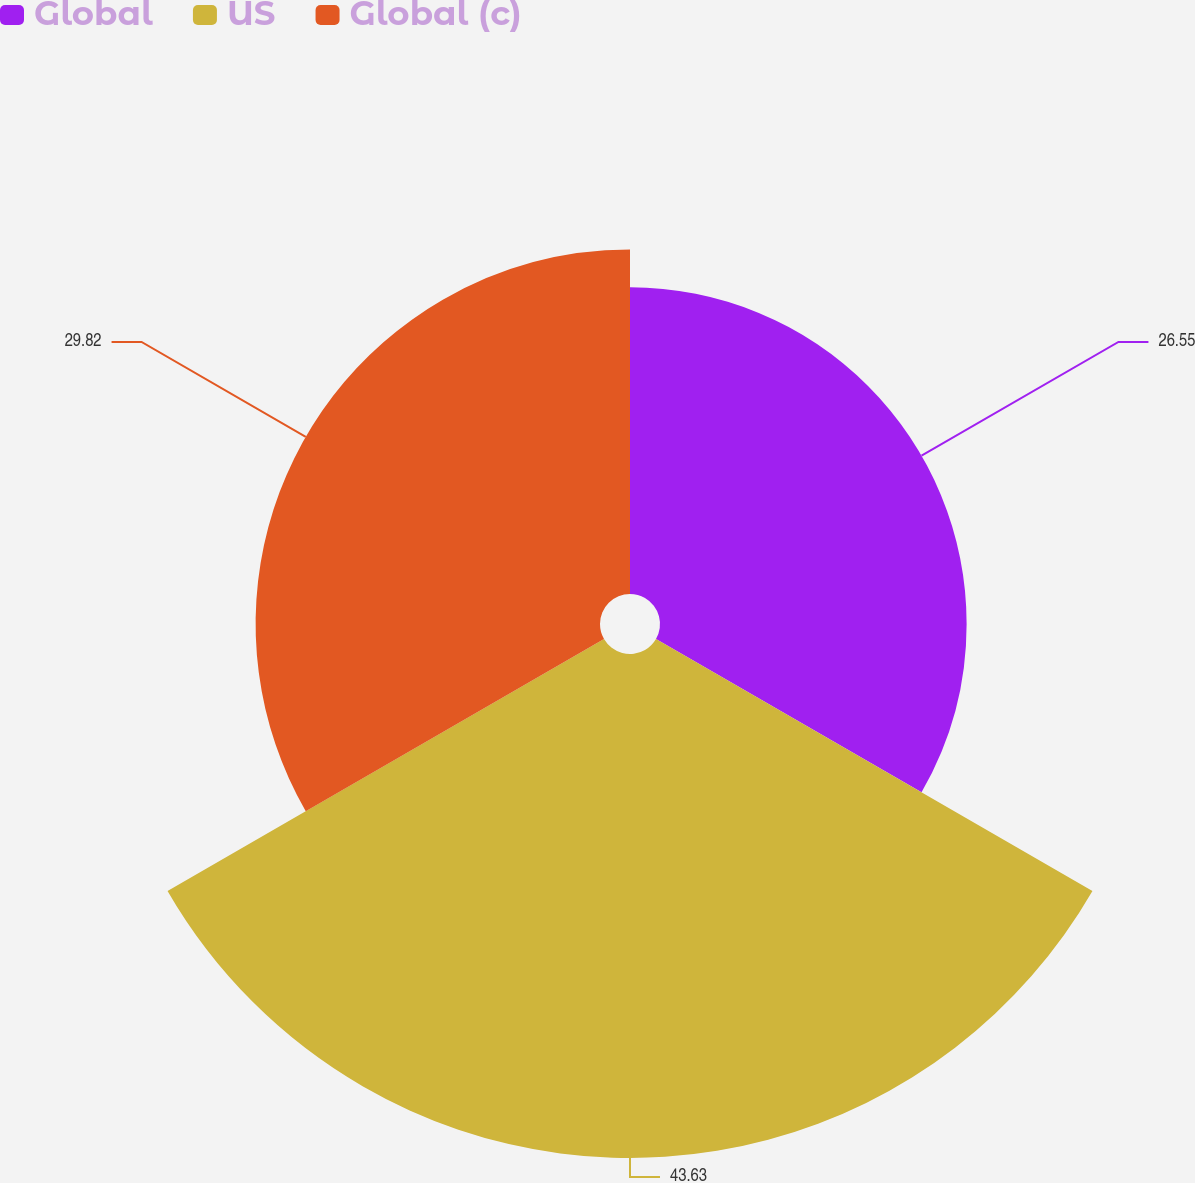<chart> <loc_0><loc_0><loc_500><loc_500><pie_chart><fcel>Global<fcel>US<fcel>Global (c)<nl><fcel>26.55%<fcel>43.64%<fcel>29.82%<nl></chart> 